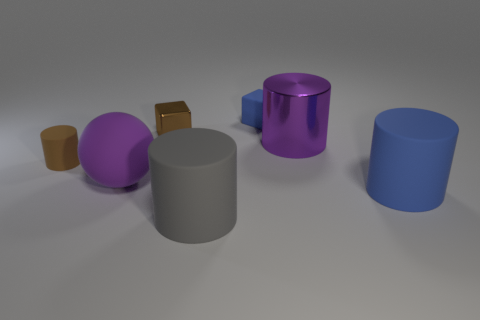Is the size of the blue matte thing that is in front of the tiny matte cylinder the same as the brown cylinder that is in front of the tiny blue thing?
Offer a very short reply. No. Is there any other thing that has the same material as the gray cylinder?
Give a very brief answer. Yes. How many big things are yellow metal spheres or shiny cubes?
Offer a very short reply. 0. How many objects are either large cylinders that are behind the large purple sphere or big green metal cubes?
Give a very brief answer. 1. Is the color of the matte ball the same as the shiny cylinder?
Ensure brevity in your answer.  Yes. What number of other objects are there of the same shape as the tiny brown metal object?
Your answer should be very brief. 1. What number of gray objects are big things or cubes?
Make the answer very short. 1. There is a small block that is the same material as the tiny brown cylinder; what color is it?
Make the answer very short. Blue. Are the brown thing that is right of the small brown rubber cylinder and the cylinder that is on the left side of the large gray rubber thing made of the same material?
Keep it short and to the point. No. There is a thing that is the same color as the metal cube; what is its size?
Ensure brevity in your answer.  Small. 